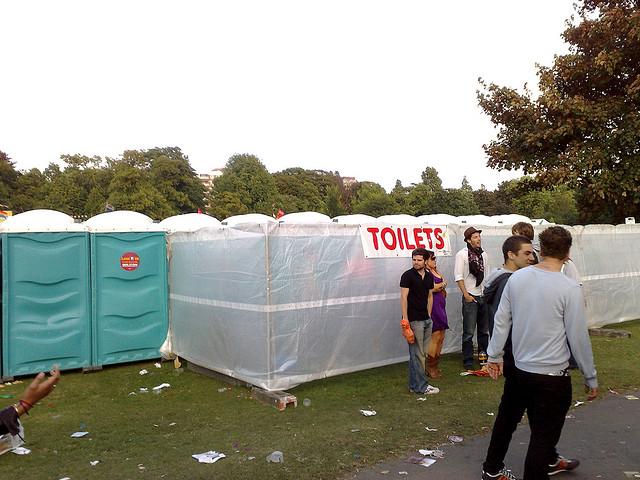Is it daytime?
Write a very short answer. Yes. What color is the lettering on the banner?
Give a very brief answer. Red. What event has likely brought these people to this place?
Concise answer only. Concert. 